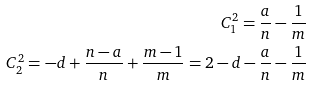<formula> <loc_0><loc_0><loc_500><loc_500>C _ { 1 } ^ { 2 } = \frac { a } { n } - \frac { 1 } { m } \\ C _ { 2 } ^ { 2 } = - d + \frac { n - a } { n } + \frac { m - 1 } { m } = 2 - d - \frac { a } { n } - \frac { 1 } { m }</formula> 